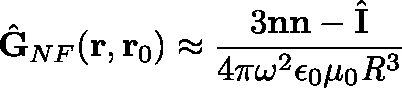Convert formula to latex. <formula><loc_0><loc_0><loc_500><loc_500>\hat { G } _ { N F } ( r , r _ { 0 } ) \approx \frac { 3 n n - \hat { I } } { 4 \pi \omega ^ { 2 } \epsilon _ { 0 } \mu _ { 0 } R ^ { 3 } }</formula> 